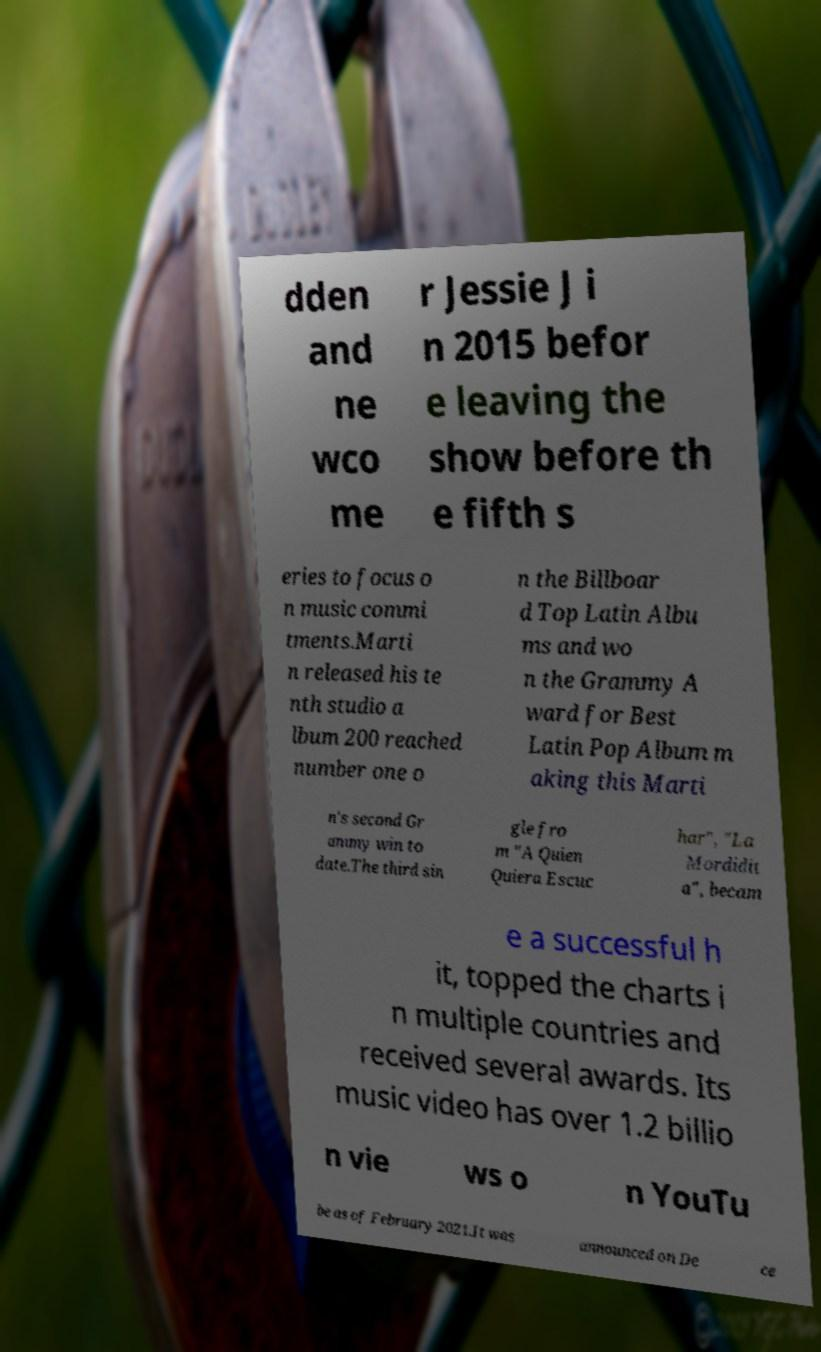Could you extract and type out the text from this image? dden and ne wco me r Jessie J i n 2015 befor e leaving the show before th e fifth s eries to focus o n music commi tments.Marti n released his te nth studio a lbum 200 reached number one o n the Billboar d Top Latin Albu ms and wo n the Grammy A ward for Best Latin Pop Album m aking this Marti n's second Gr ammy win to date.The third sin gle fro m "A Quien Quiera Escuc har", "La Mordidit a", becam e a successful h it, topped the charts i n multiple countries and received several awards. Its music video has over 1.2 billio n vie ws o n YouTu be as of February 2021.It was announced on De ce 